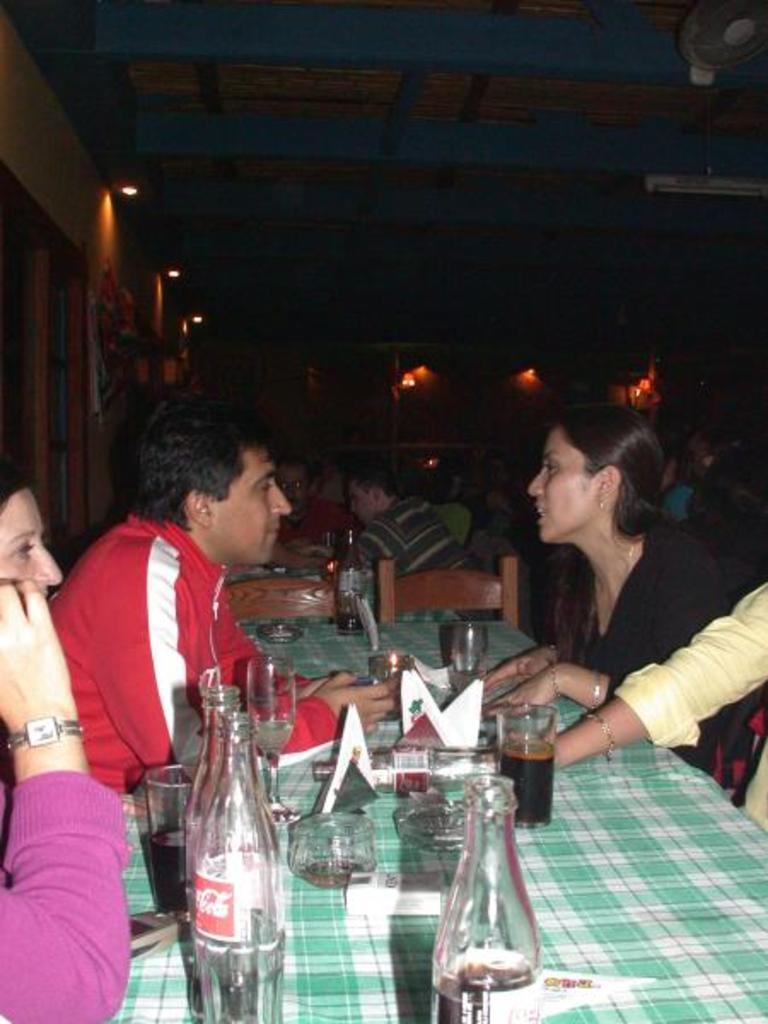Please provide a concise description of this image. This image is clicked in a restaurant. There are lights on the top. There is a cloth on the table, cold drinks, tissues, bottles. There are people sitting on chair around the table. There is a table fan on the top right corner. 